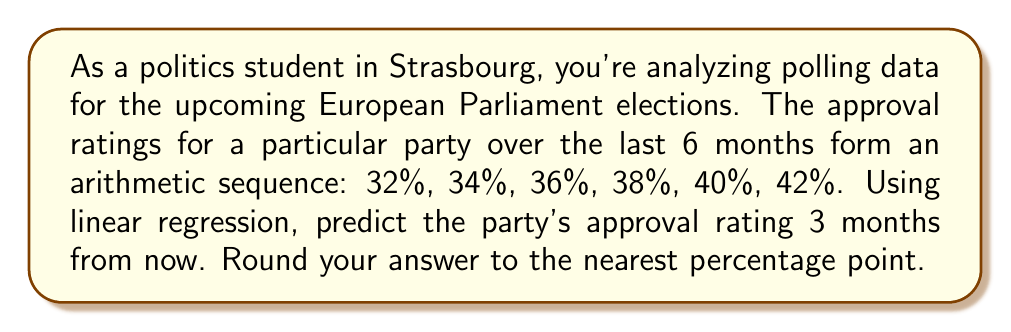Can you answer this question? Let's approach this step-by-step:

1) First, we need to identify the arithmetic sequence:
   $32, 34, 36, 38, 40, 42$

2) The common difference $d$ is:
   $d = 34 - 32 = 36 - 34 = ... = 42 - 40 = 2$

3) We can represent this sequence as a linear function:
   $y = mx + b$, where $x$ is the month number (0 to 5) and $y$ is the approval rating.

4) To find $m$ (slope), we use:
   $m = \frac{\text{change in y}}{\text{change in x}} = \frac{42 - 32}{5 - 0} = \frac{10}{5} = 2$

5) To find $b$ (y-intercept), we can use any point, let's use (0, 32):
   $32 = 2(0) + b$
   $b = 32$

6) Our linear regression equation is:
   $y = 2x + 32$

7) To predict 3 months from now, we need $x = 8$ (as we already have 6 months of data):
   $y = 2(8) + 32 = 16 + 32 = 48$

8) Rounding to the nearest percentage point:
   $48\%$
Answer: 48% 